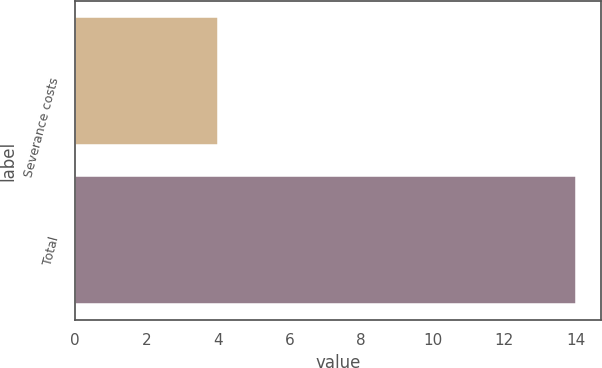<chart> <loc_0><loc_0><loc_500><loc_500><bar_chart><fcel>Severance costs<fcel>Total<nl><fcel>4<fcel>14<nl></chart> 